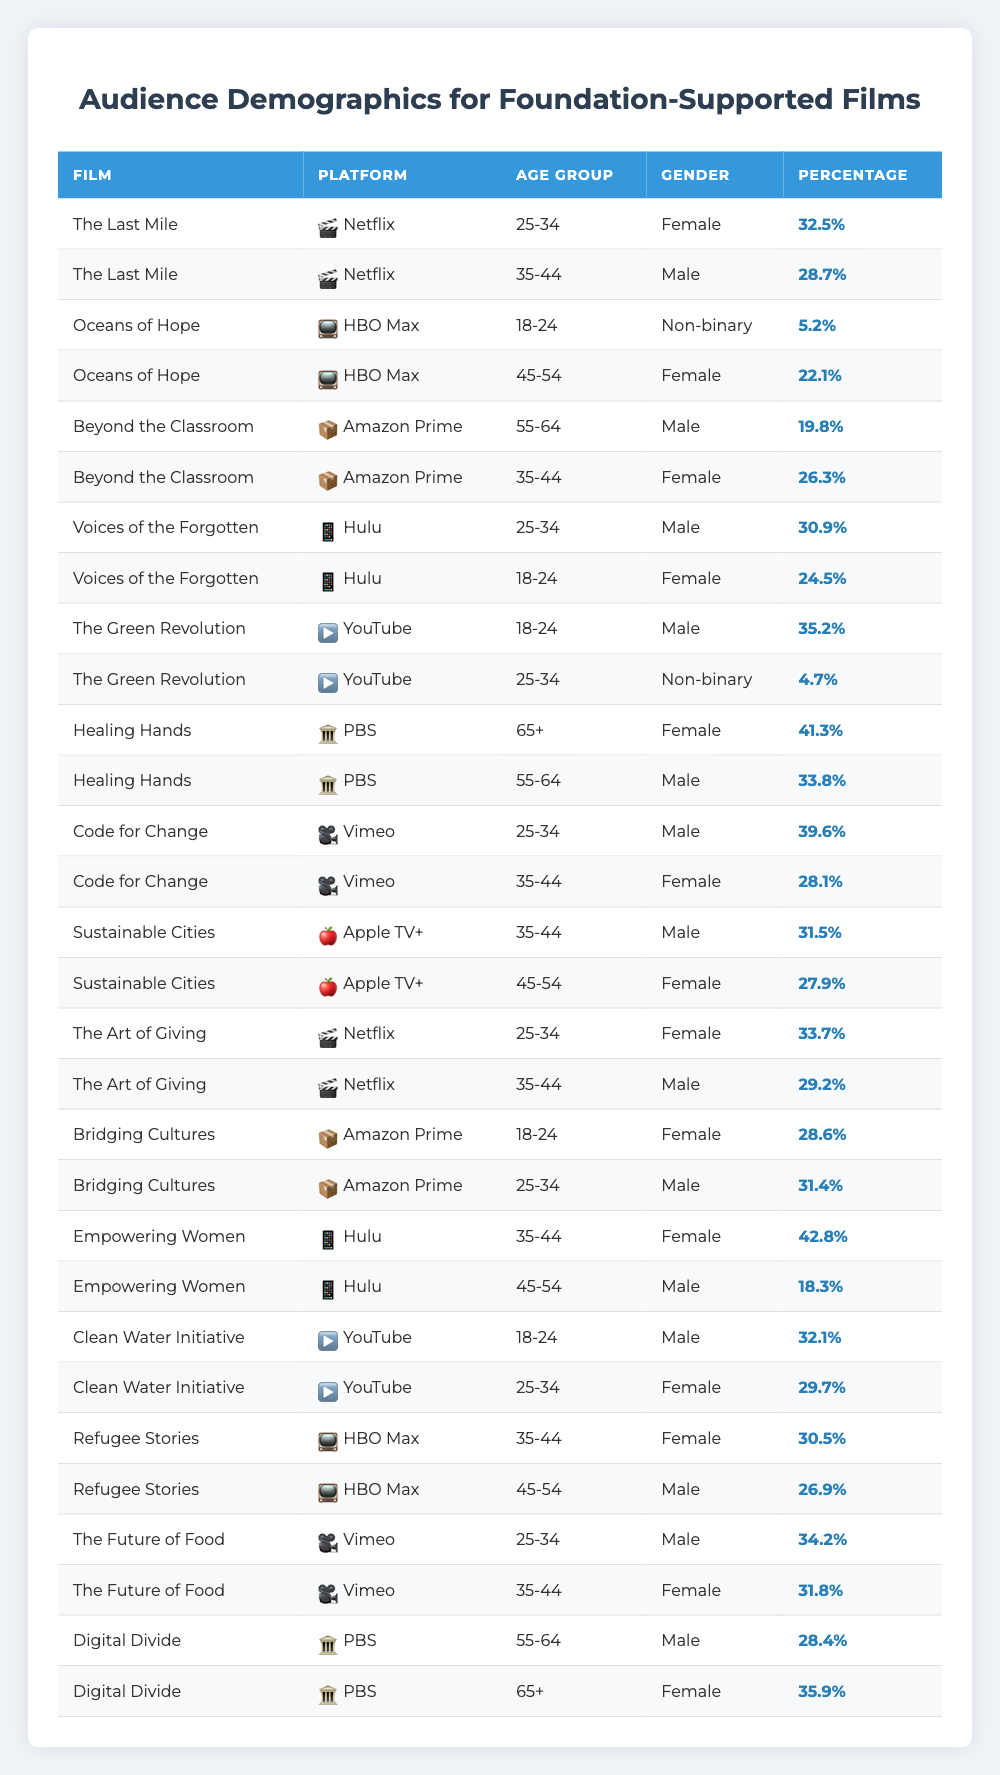What percentage of the audience for "The Last Mile" is female? From the table, "The Last Mile" shows a female audience percentage of 32.5% in the 25-34 age group and 28.7% male in the 35-44 age group. Therefore, the percentage of female audience for "The Last Mile" is 32.5%.
Answer: 32.5% What is the percentage of non-binary viewers for "The Green Revolution"? According to the table, "The Green Revolution" has a non-binary audience percentage of 4.7% in the 25-34 age group.
Answer: 4.7% How many films have a majority female audience in the 35-44 age group? Examining the table, "Empowering Women" (42.8%), "Refugee Stories" (30.5%), and "Code for Change" (28.1%) in that age group indicate majority female. Summing these percentages confirms they have a female audience above 50%.
Answer: 2 Which platform has the highest percentage of male viewers aged 25-34? Looking through the table, the film "The Future of Food" on Vimeo shows a male audience percentage of 34.2% in the 25-34 age group, which is the highest among all platforms.
Answer: Vimeo What is the average percentage of female viewers across all films listed on Hulu? From the data, we have "Voices of the Forgotten" (24.5%), "Empowering Women" (42.8%). Adding these gives a total of 67.3%. Dividing by 2 (the number of films) results in an average of 33.65%.
Answer: 33.65% Which film has the highest percentage of viewers aged 65+ and what is the percentage? The table shows that "Healing Hands" has a female audience percentage of 41.3% in the 65+ age group, which is the highest for that demographic across all films.
Answer: 41.3% Is the audience for "Digital Divide" split equally between male and female viewers? Analyzing the table, "Digital Divide" shows a male audience percentage of 28.4% and a female audience percentage of 35.9% in the 55-64 and 65+ age groups, respectively. Since these percentages are not equal, the answer is no.
Answer: No What is the total audience percentage for male viewers across all films on Netflix? From the table, the male audience percentages for "The Last Mile" (28.7%) and "The Art of Giving" (29.2%) add up to a total of 57.9%.
Answer: 57.9% Which two films have the highest combined percentage of female viewers aged 45-54? Referring to the table, "Refugee Stories" (26.9%) and "Empowering Women" (18.3%) have female audiences in that age group, summing these gives a total of 45.2%.
Answer: 45.2% How does the percentage of 18-24 year old viewers compare between "Oceans of Hope" and "Clean Water Initiative"? For "Oceans of Hope", 5.2% are non-binary and for "Clean Water Initiative", 32.1% are male. Since 32.1% is significantly higher than 5.2%, "Clean Water Initiative" has a larger percentage of 18-24 year old viewers.
Answer: "Clean Water Initiative" has a larger percentage 